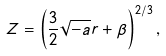Convert formula to latex. <formula><loc_0><loc_0><loc_500><loc_500>Z = \left ( \frac { 3 } { 2 } \sqrt { - a } r + \beta \right ) ^ { 2 / 3 } ,</formula> 